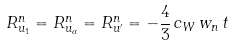<formula> <loc_0><loc_0><loc_500><loc_500>R _ { u _ { 1 } } ^ { n } = R _ { u _ { \alpha } } ^ { n } = R _ { u ^ { \prime } } ^ { n } = - \frac { 4 } { 3 } \, c _ { W } \, w _ { n } \, t</formula> 